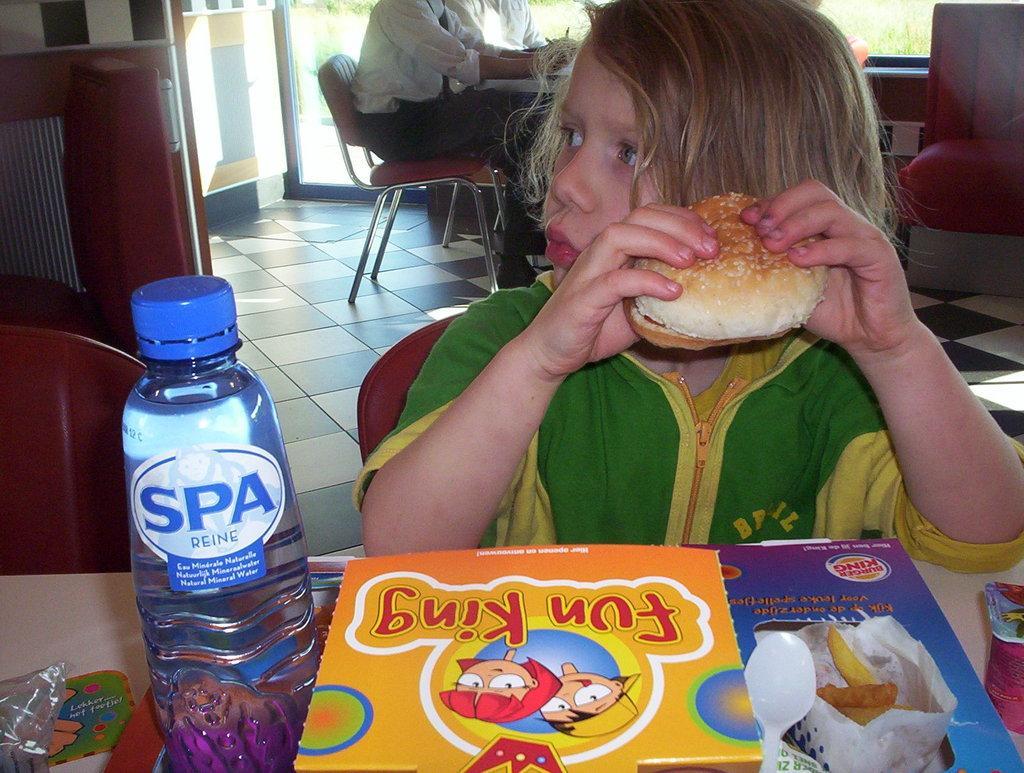Please provide a concise description of this image. Boy in blue jacket who is sitting on the chair is holding burger in his hand and in front of him, we see a white table on which book, water bottle and plastic cover are placed. Behind him, we see two people sitting on chair and behind them, we see a window from which we see grass. 